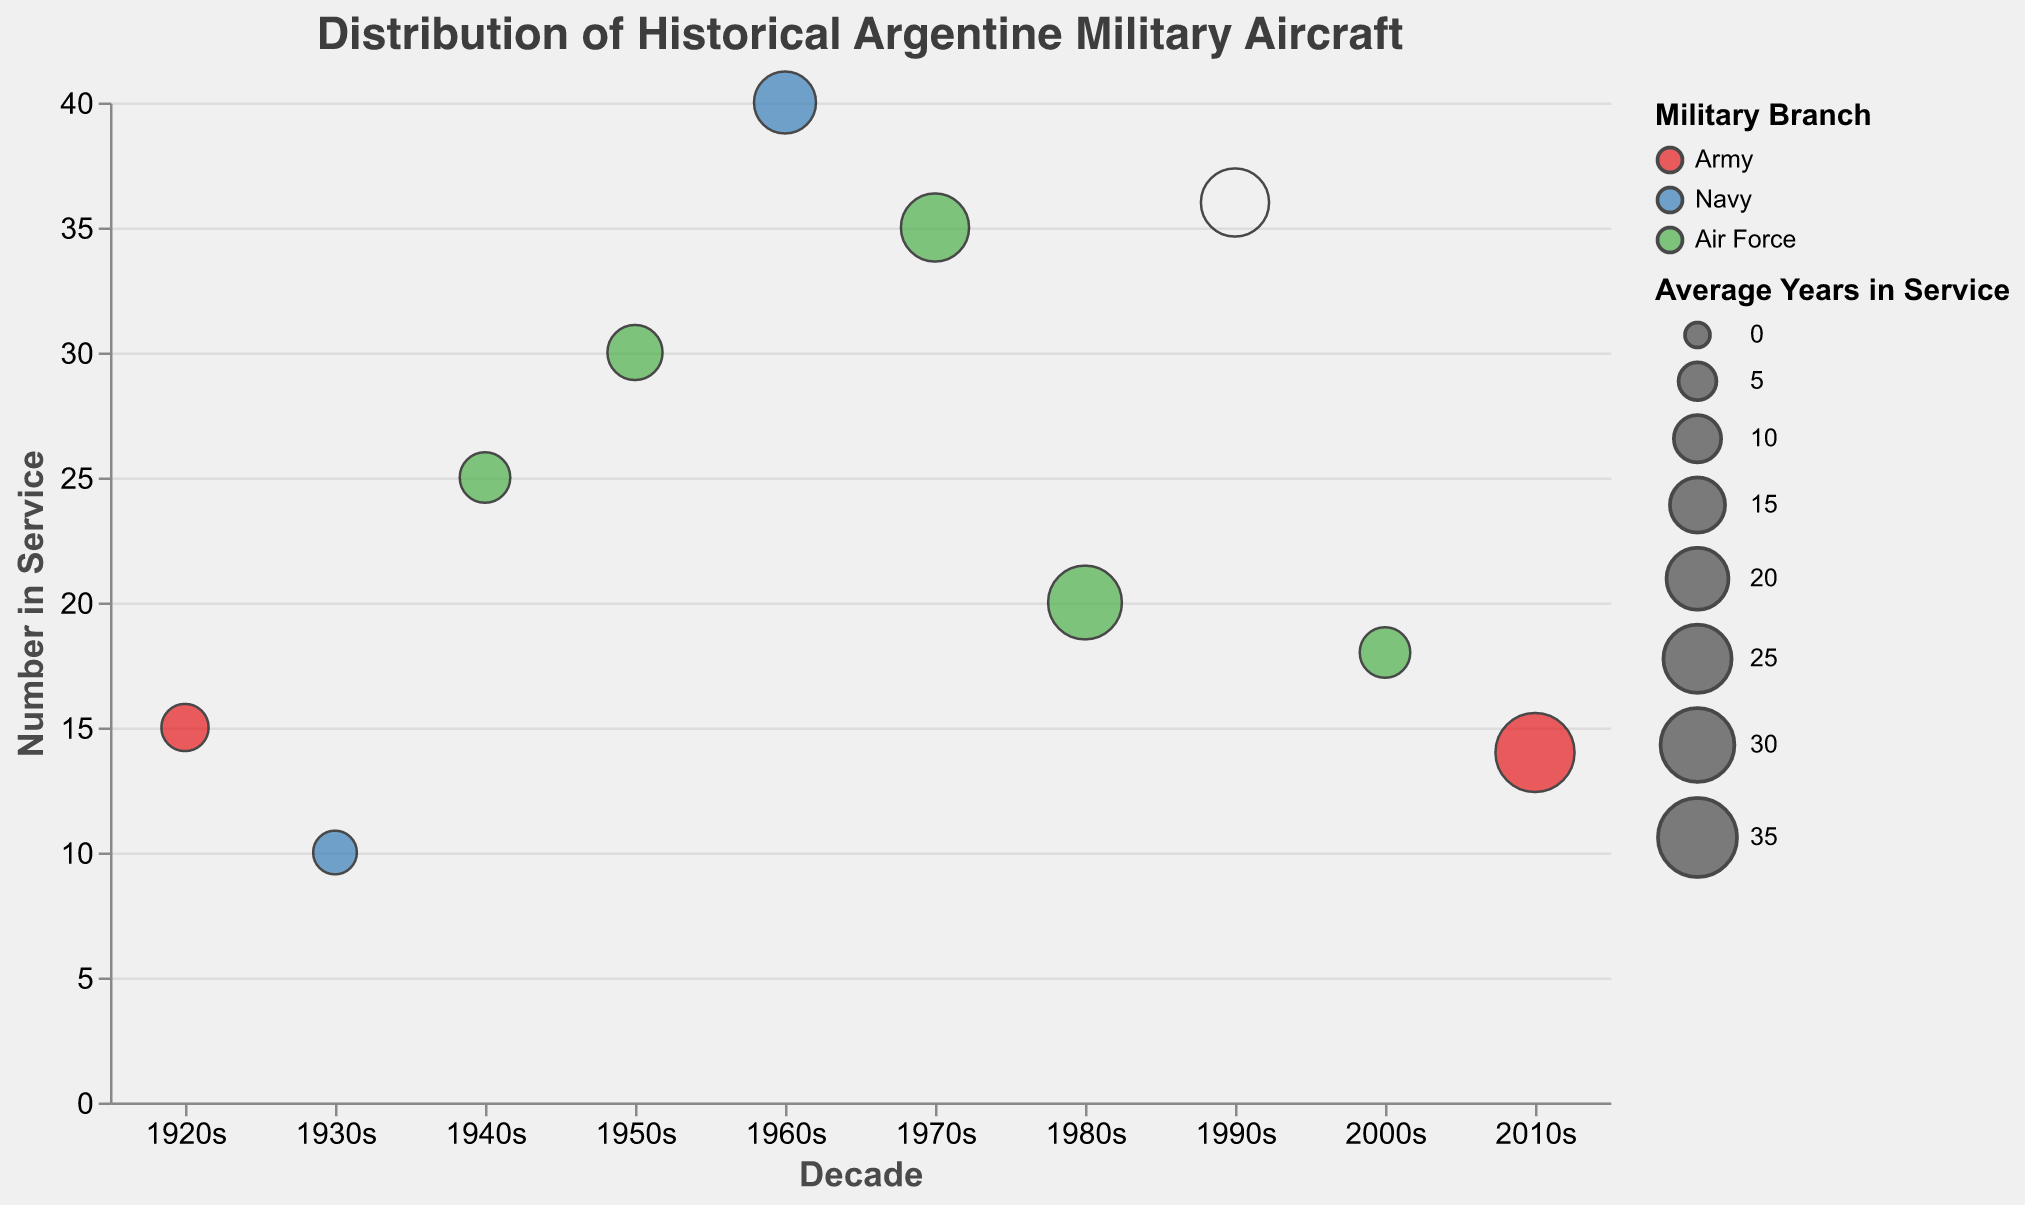What's the title of the figure? The title of the figure is usually placed at the top and describes the content of the chart. Look for the text located at the uppermost part of the chart.
Answer: Distribution of Historical Argentine Military Aircraft Which decade had the most aircraft in service? To find the decade with the most aircraft in service, look for the bubble positioned highest on the y-axis as it represents the number in service.
Answer: 1960s What branch of the military has a bubble with the largest size? The size of a bubble corresponds to the average years in service. The largest bubble should be visually identified and noted for its color, which indicates the military branch.
Answer: Army How many different decades are represented in the chart? Count the distinct x-axis tick labels; each represents a different decade.
Answer: 10 Which aircraft model served the longest on average, and how many years did it serve? Hover over or look closely at each bubble for the average years in service, noted in the tooltip. The model with the highest number represents the longest service.
Answer: FMA IA 58 Pucará, 35 years Compare the number of aircraft in service in the 1920s to the 2010s. Which decade had more? Identify the bubbles for both decades and compare their positions on the y-axis. The higher bubble represents more aircraft in service.
Answer: 1920s Which aircraft model from the Navy had the highest number of aircraft in service? Identify the blue-colored bubbles since they represent the Navy and find which one is highest on the y-axis.
Answer: Douglas A-4 Skyhawk What is the trend of the average years in service for Air Force aircraft across the decades? Follow the green-colored bubbles and notice the trends in the size of the bubbles, which correspond to the average years in service.
Answer: Increasing How many different branches are displayed in the chart, and what are they? Check the legend for the number of different categories and their corresponding colors.
Answer: Three branches: Army, Navy, Air Force Which decade has the bubbles with the largest size representing the Army? Identify which decade on the x-axis has the largest-sized Red-colored bubble.
Answer: 2010s 